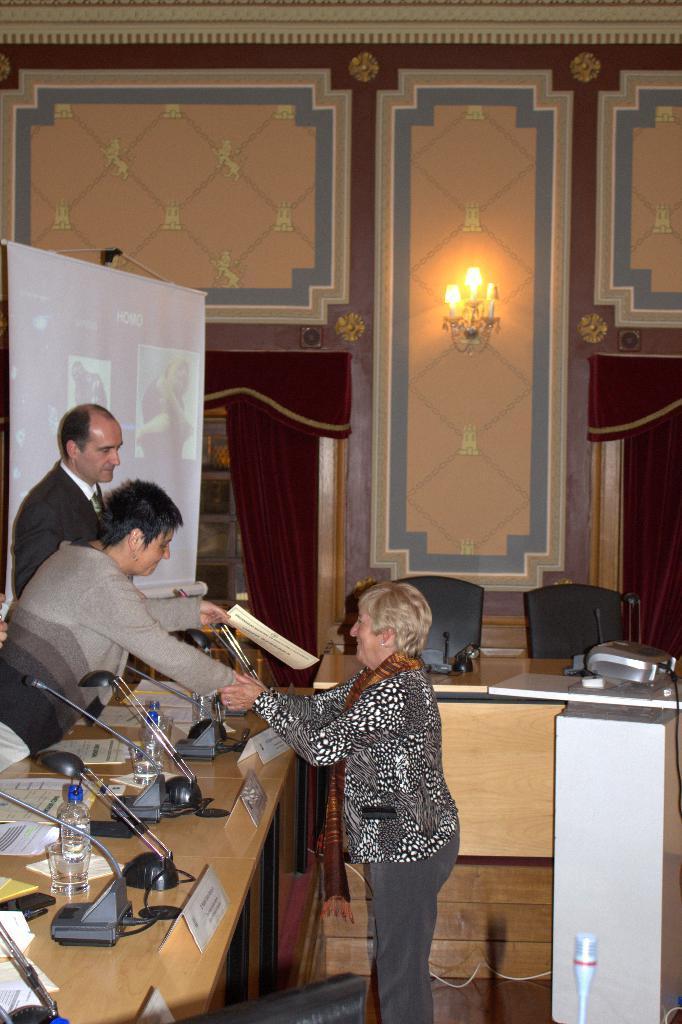How would you summarize this image in a sentence or two? The women in the right is shaking her hands in front of another women standing and there is another person standing beside her and there is a projected image in the background. 